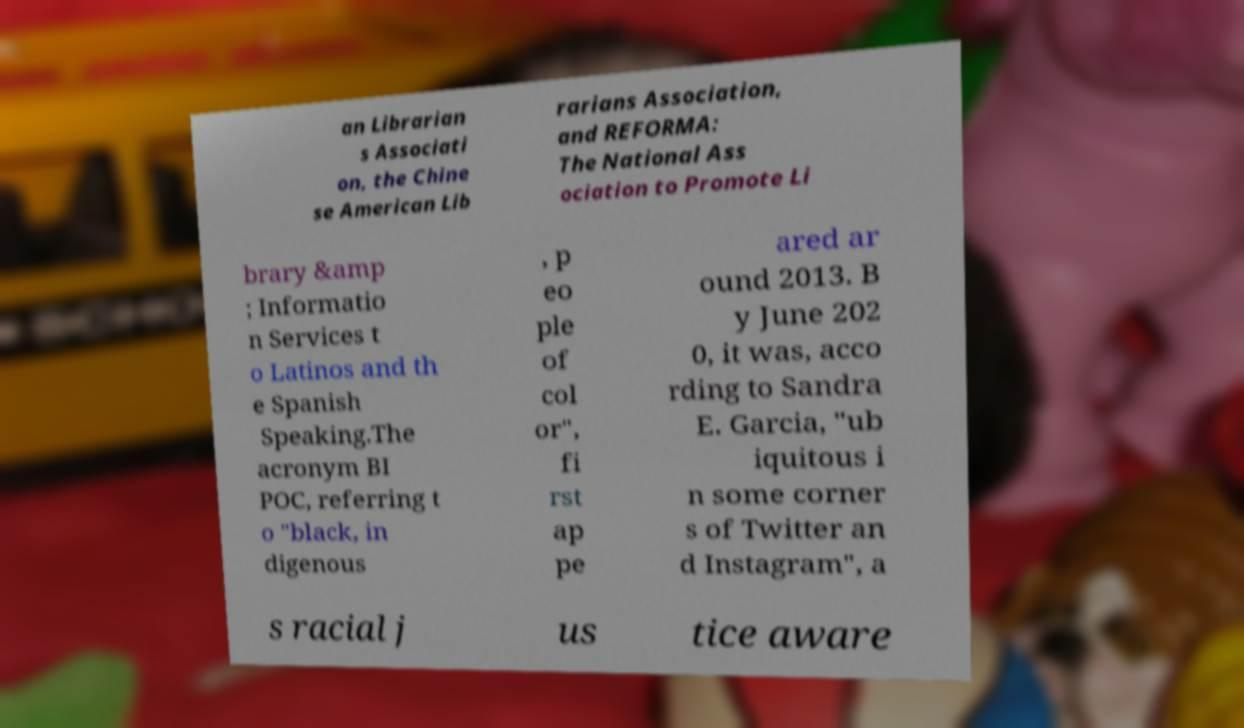Can you accurately transcribe the text from the provided image for me? an Librarian s Associati on, the Chine se American Lib rarians Association, and REFORMA: The National Ass ociation to Promote Li brary &amp ; Informatio n Services t o Latinos and th e Spanish Speaking.The acronym BI POC, referring t o "black, in digenous , p eo ple of col or", fi rst ap pe ared ar ound 2013. B y June 202 0, it was, acco rding to Sandra E. Garcia, "ub iquitous i n some corner s of Twitter an d Instagram", a s racial j us tice aware 